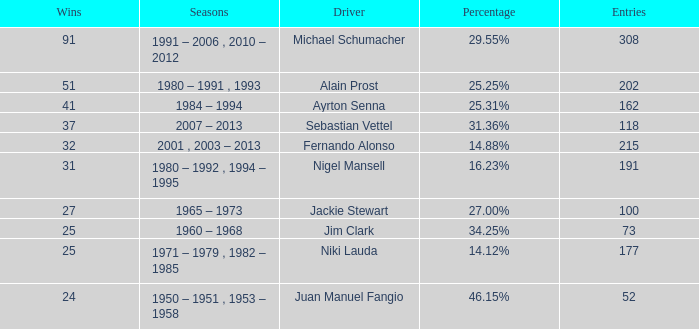Which driver has 162 entries? Ayrton Senna. 